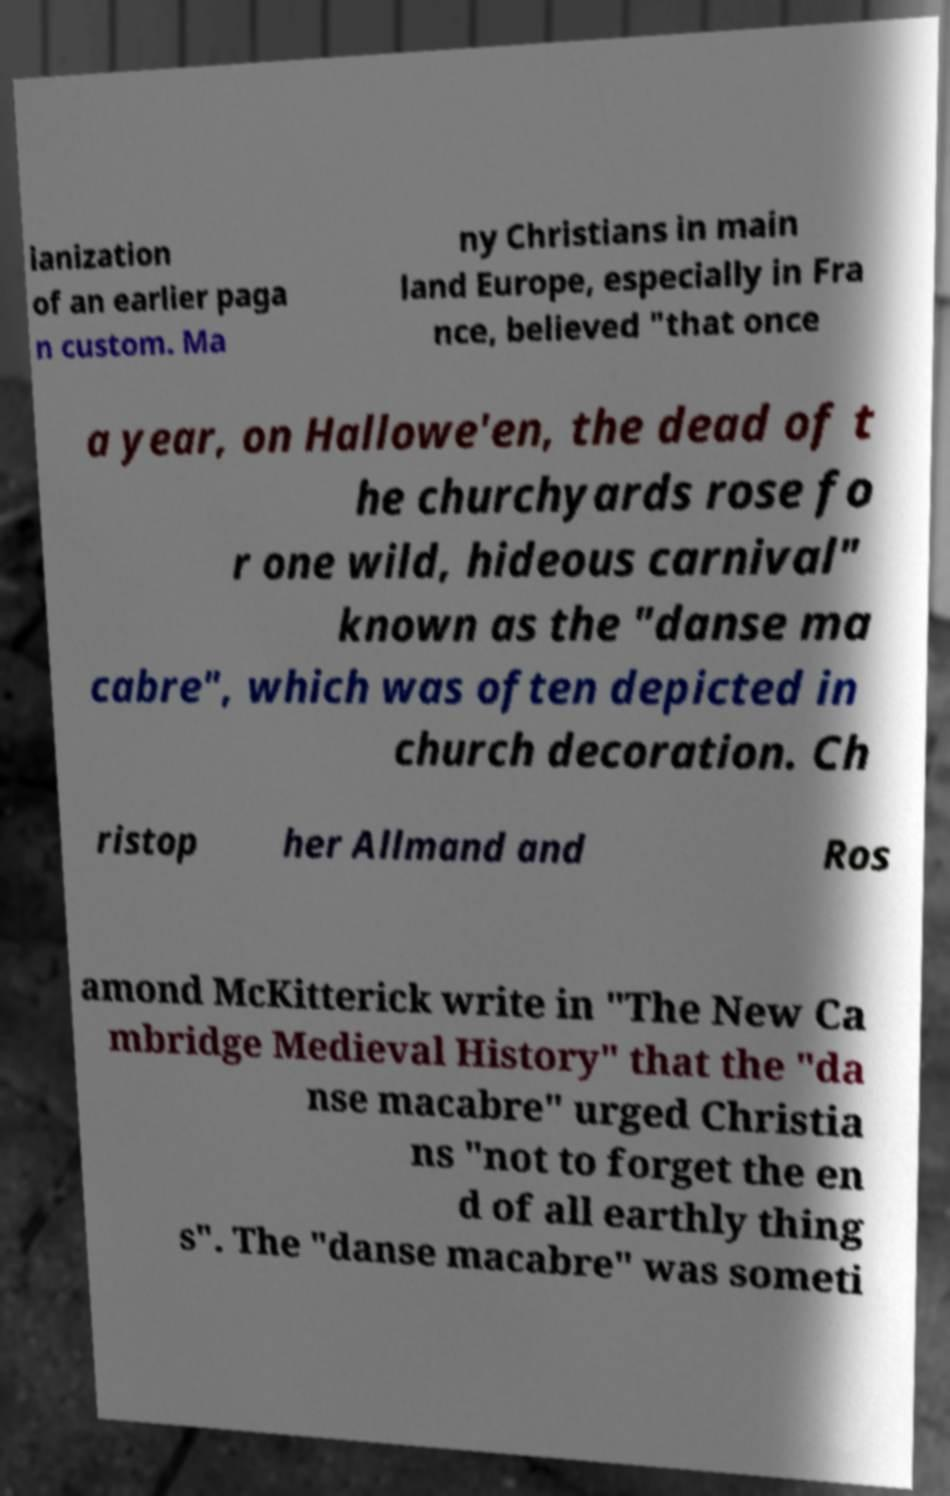There's text embedded in this image that I need extracted. Can you transcribe it verbatim? ianization of an earlier paga n custom. Ma ny Christians in main land Europe, especially in Fra nce, believed "that once a year, on Hallowe'en, the dead of t he churchyards rose fo r one wild, hideous carnival" known as the "danse ma cabre", which was often depicted in church decoration. Ch ristop her Allmand and Ros amond McKitterick write in "The New Ca mbridge Medieval History" that the "da nse macabre" urged Christia ns "not to forget the en d of all earthly thing s". The "danse macabre" was someti 